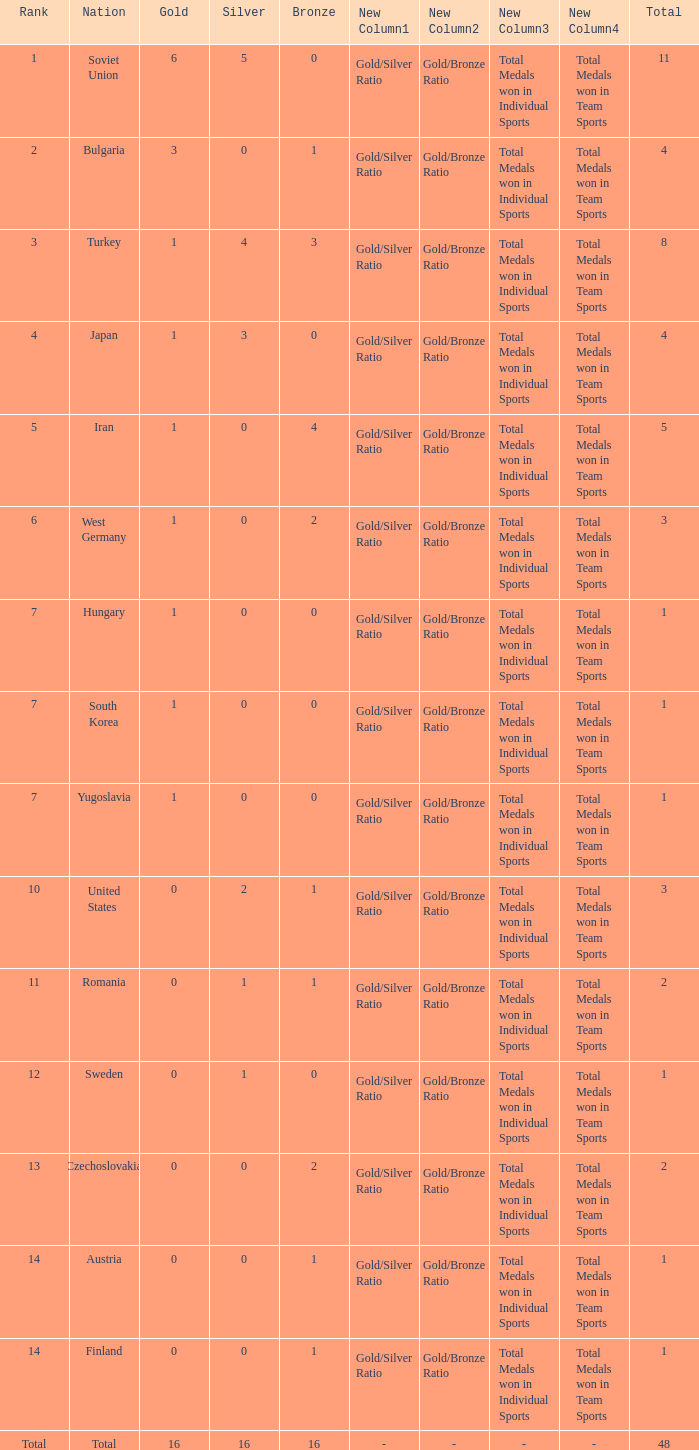How many total golds do teams have when the total medals is less than 1? None. 